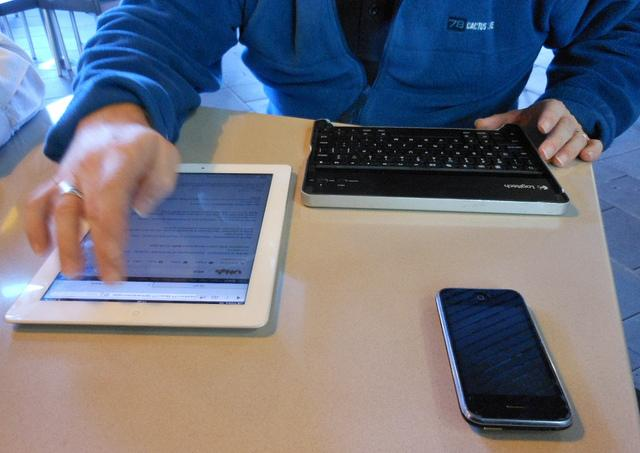Why is he touching the screen? using tablet 